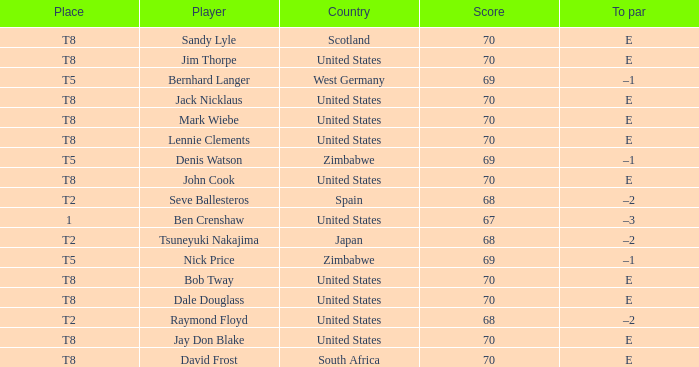What player has E as the to par, and The United States as the country? Jay Don Blake, Lennie Clements, John Cook, Dale Douglass, Jack Nicklaus, Jim Thorpe, Bob Tway, Mark Wiebe. 